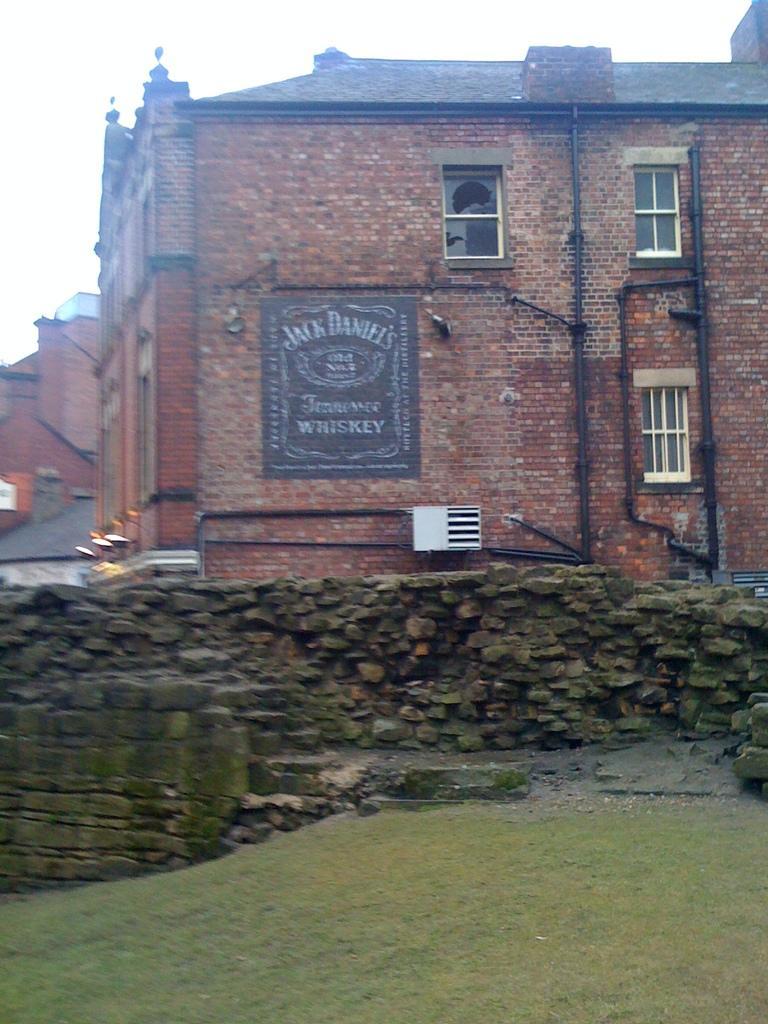How would you summarize this image in a sentence or two? At the bottom of the image there is grass on the surface. There is a rock wall. In the background of the image there are buildings, lights and sky. 